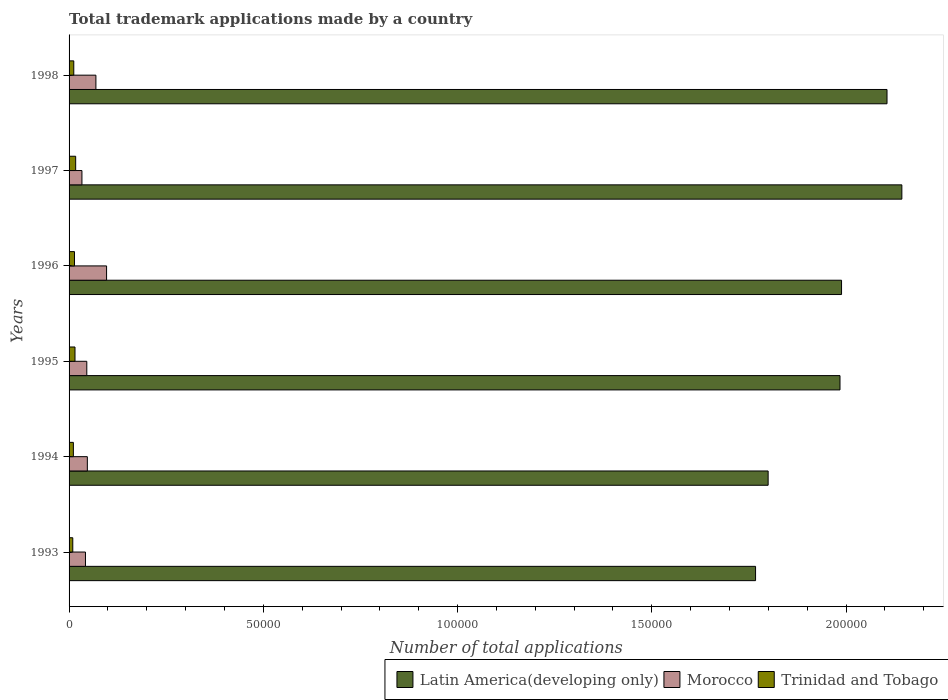How many different coloured bars are there?
Provide a succinct answer. 3. How many groups of bars are there?
Your answer should be compact. 6. How many bars are there on the 4th tick from the top?
Provide a short and direct response. 3. What is the label of the 3rd group of bars from the top?
Your answer should be compact. 1996. In how many cases, is the number of bars for a given year not equal to the number of legend labels?
Keep it short and to the point. 0. What is the number of applications made by in Latin America(developing only) in 1998?
Offer a very short reply. 2.11e+05. Across all years, what is the maximum number of applications made by in Morocco?
Provide a short and direct response. 9654. Across all years, what is the minimum number of applications made by in Morocco?
Offer a very short reply. 3312. What is the total number of applications made by in Trinidad and Tobago in the graph?
Your answer should be very brief. 7897. What is the difference between the number of applications made by in Morocco in 1993 and that in 1998?
Your response must be concise. -2688. What is the difference between the number of applications made by in Morocco in 1995 and the number of applications made by in Trinidad and Tobago in 1997?
Your answer should be very brief. 2865. What is the average number of applications made by in Morocco per year?
Your answer should be very brief. 5560. In the year 1993, what is the difference between the number of applications made by in Trinidad and Tobago and number of applications made by in Morocco?
Give a very brief answer. -3263. In how many years, is the number of applications made by in Trinidad and Tobago greater than 90000 ?
Keep it short and to the point. 0. What is the ratio of the number of applications made by in Trinidad and Tobago in 1996 to that in 1998?
Your answer should be very brief. 1.15. Is the difference between the number of applications made by in Trinidad and Tobago in 1993 and 1995 greater than the difference between the number of applications made by in Morocco in 1993 and 1995?
Give a very brief answer. No. What is the difference between the highest and the second highest number of applications made by in Latin America(developing only)?
Ensure brevity in your answer.  3819. What is the difference between the highest and the lowest number of applications made by in Latin America(developing only)?
Offer a very short reply. 3.77e+04. Is the sum of the number of applications made by in Trinidad and Tobago in 1994 and 1996 greater than the maximum number of applications made by in Morocco across all years?
Provide a short and direct response. No. What does the 3rd bar from the top in 1994 represents?
Your response must be concise. Latin America(developing only). What does the 3rd bar from the bottom in 1994 represents?
Give a very brief answer. Trinidad and Tobago. How many bars are there?
Your response must be concise. 18. Are all the bars in the graph horizontal?
Provide a succinct answer. Yes. What is the difference between two consecutive major ticks on the X-axis?
Offer a terse response. 5.00e+04. Are the values on the major ticks of X-axis written in scientific E-notation?
Provide a succinct answer. No. Does the graph contain grids?
Give a very brief answer. No. Where does the legend appear in the graph?
Offer a very short reply. Bottom right. How many legend labels are there?
Make the answer very short. 3. How are the legend labels stacked?
Your answer should be compact. Horizontal. What is the title of the graph?
Provide a succinct answer. Total trademark applications made by a country. Does "Kiribati" appear as one of the legend labels in the graph?
Ensure brevity in your answer.  No. What is the label or title of the X-axis?
Your answer should be very brief. Number of total applications. What is the Number of total applications of Latin America(developing only) in 1993?
Ensure brevity in your answer.  1.77e+05. What is the Number of total applications of Morocco in 1993?
Make the answer very short. 4220. What is the Number of total applications of Trinidad and Tobago in 1993?
Your answer should be compact. 957. What is the Number of total applications of Latin America(developing only) in 1994?
Give a very brief answer. 1.80e+05. What is the Number of total applications of Morocco in 1994?
Provide a succinct answer. 4702. What is the Number of total applications of Trinidad and Tobago in 1994?
Offer a very short reply. 1107. What is the Number of total applications in Latin America(developing only) in 1995?
Your answer should be compact. 1.98e+05. What is the Number of total applications of Morocco in 1995?
Provide a succinct answer. 4564. What is the Number of total applications of Trinidad and Tobago in 1995?
Provide a short and direct response. 1525. What is the Number of total applications in Latin America(developing only) in 1996?
Your answer should be compact. 1.99e+05. What is the Number of total applications of Morocco in 1996?
Your answer should be very brief. 9654. What is the Number of total applications in Trinidad and Tobago in 1996?
Provide a short and direct response. 1395. What is the Number of total applications of Latin America(developing only) in 1997?
Make the answer very short. 2.14e+05. What is the Number of total applications of Morocco in 1997?
Give a very brief answer. 3312. What is the Number of total applications of Trinidad and Tobago in 1997?
Offer a very short reply. 1699. What is the Number of total applications of Latin America(developing only) in 1998?
Keep it short and to the point. 2.11e+05. What is the Number of total applications in Morocco in 1998?
Ensure brevity in your answer.  6908. What is the Number of total applications of Trinidad and Tobago in 1998?
Offer a terse response. 1214. Across all years, what is the maximum Number of total applications of Latin America(developing only)?
Your answer should be very brief. 2.14e+05. Across all years, what is the maximum Number of total applications of Morocco?
Keep it short and to the point. 9654. Across all years, what is the maximum Number of total applications in Trinidad and Tobago?
Provide a succinct answer. 1699. Across all years, what is the minimum Number of total applications of Latin America(developing only)?
Your answer should be very brief. 1.77e+05. Across all years, what is the minimum Number of total applications of Morocco?
Your answer should be very brief. 3312. Across all years, what is the minimum Number of total applications in Trinidad and Tobago?
Give a very brief answer. 957. What is the total Number of total applications in Latin America(developing only) in the graph?
Your answer should be very brief. 1.18e+06. What is the total Number of total applications of Morocco in the graph?
Provide a short and direct response. 3.34e+04. What is the total Number of total applications in Trinidad and Tobago in the graph?
Provide a succinct answer. 7897. What is the difference between the Number of total applications of Latin America(developing only) in 1993 and that in 1994?
Keep it short and to the point. -3239. What is the difference between the Number of total applications of Morocco in 1993 and that in 1994?
Offer a terse response. -482. What is the difference between the Number of total applications in Trinidad and Tobago in 1993 and that in 1994?
Your answer should be compact. -150. What is the difference between the Number of total applications of Latin America(developing only) in 1993 and that in 1995?
Keep it short and to the point. -2.17e+04. What is the difference between the Number of total applications of Morocco in 1993 and that in 1995?
Keep it short and to the point. -344. What is the difference between the Number of total applications in Trinidad and Tobago in 1993 and that in 1995?
Your answer should be compact. -568. What is the difference between the Number of total applications of Latin America(developing only) in 1993 and that in 1996?
Ensure brevity in your answer.  -2.21e+04. What is the difference between the Number of total applications in Morocco in 1993 and that in 1996?
Ensure brevity in your answer.  -5434. What is the difference between the Number of total applications of Trinidad and Tobago in 1993 and that in 1996?
Your answer should be compact. -438. What is the difference between the Number of total applications of Latin America(developing only) in 1993 and that in 1997?
Keep it short and to the point. -3.77e+04. What is the difference between the Number of total applications in Morocco in 1993 and that in 1997?
Provide a short and direct response. 908. What is the difference between the Number of total applications of Trinidad and Tobago in 1993 and that in 1997?
Provide a succinct answer. -742. What is the difference between the Number of total applications of Latin America(developing only) in 1993 and that in 1998?
Ensure brevity in your answer.  -3.38e+04. What is the difference between the Number of total applications of Morocco in 1993 and that in 1998?
Provide a succinct answer. -2688. What is the difference between the Number of total applications in Trinidad and Tobago in 1993 and that in 1998?
Keep it short and to the point. -257. What is the difference between the Number of total applications in Latin America(developing only) in 1994 and that in 1995?
Offer a terse response. -1.85e+04. What is the difference between the Number of total applications of Morocco in 1994 and that in 1995?
Ensure brevity in your answer.  138. What is the difference between the Number of total applications in Trinidad and Tobago in 1994 and that in 1995?
Your response must be concise. -418. What is the difference between the Number of total applications of Latin America(developing only) in 1994 and that in 1996?
Make the answer very short. -1.89e+04. What is the difference between the Number of total applications of Morocco in 1994 and that in 1996?
Offer a very short reply. -4952. What is the difference between the Number of total applications of Trinidad and Tobago in 1994 and that in 1996?
Provide a short and direct response. -288. What is the difference between the Number of total applications in Latin America(developing only) in 1994 and that in 1997?
Your answer should be very brief. -3.44e+04. What is the difference between the Number of total applications of Morocco in 1994 and that in 1997?
Your answer should be very brief. 1390. What is the difference between the Number of total applications of Trinidad and Tobago in 1994 and that in 1997?
Offer a very short reply. -592. What is the difference between the Number of total applications of Latin America(developing only) in 1994 and that in 1998?
Offer a very short reply. -3.06e+04. What is the difference between the Number of total applications of Morocco in 1994 and that in 1998?
Offer a terse response. -2206. What is the difference between the Number of total applications of Trinidad and Tobago in 1994 and that in 1998?
Provide a short and direct response. -107. What is the difference between the Number of total applications in Latin America(developing only) in 1995 and that in 1996?
Make the answer very short. -396. What is the difference between the Number of total applications of Morocco in 1995 and that in 1996?
Make the answer very short. -5090. What is the difference between the Number of total applications of Trinidad and Tobago in 1995 and that in 1996?
Make the answer very short. 130. What is the difference between the Number of total applications of Latin America(developing only) in 1995 and that in 1997?
Provide a short and direct response. -1.59e+04. What is the difference between the Number of total applications in Morocco in 1995 and that in 1997?
Provide a short and direct response. 1252. What is the difference between the Number of total applications of Trinidad and Tobago in 1995 and that in 1997?
Offer a terse response. -174. What is the difference between the Number of total applications in Latin America(developing only) in 1995 and that in 1998?
Provide a short and direct response. -1.21e+04. What is the difference between the Number of total applications of Morocco in 1995 and that in 1998?
Provide a succinct answer. -2344. What is the difference between the Number of total applications of Trinidad and Tobago in 1995 and that in 1998?
Give a very brief answer. 311. What is the difference between the Number of total applications in Latin America(developing only) in 1996 and that in 1997?
Offer a terse response. -1.55e+04. What is the difference between the Number of total applications of Morocco in 1996 and that in 1997?
Offer a terse response. 6342. What is the difference between the Number of total applications of Trinidad and Tobago in 1996 and that in 1997?
Provide a short and direct response. -304. What is the difference between the Number of total applications in Latin America(developing only) in 1996 and that in 1998?
Offer a terse response. -1.17e+04. What is the difference between the Number of total applications in Morocco in 1996 and that in 1998?
Provide a succinct answer. 2746. What is the difference between the Number of total applications of Trinidad and Tobago in 1996 and that in 1998?
Your answer should be very brief. 181. What is the difference between the Number of total applications of Latin America(developing only) in 1997 and that in 1998?
Ensure brevity in your answer.  3819. What is the difference between the Number of total applications of Morocco in 1997 and that in 1998?
Provide a succinct answer. -3596. What is the difference between the Number of total applications in Trinidad and Tobago in 1997 and that in 1998?
Provide a succinct answer. 485. What is the difference between the Number of total applications of Latin America(developing only) in 1993 and the Number of total applications of Morocco in 1994?
Provide a succinct answer. 1.72e+05. What is the difference between the Number of total applications of Latin America(developing only) in 1993 and the Number of total applications of Trinidad and Tobago in 1994?
Give a very brief answer. 1.76e+05. What is the difference between the Number of total applications of Morocco in 1993 and the Number of total applications of Trinidad and Tobago in 1994?
Give a very brief answer. 3113. What is the difference between the Number of total applications in Latin America(developing only) in 1993 and the Number of total applications in Morocco in 1995?
Provide a short and direct response. 1.72e+05. What is the difference between the Number of total applications of Latin America(developing only) in 1993 and the Number of total applications of Trinidad and Tobago in 1995?
Make the answer very short. 1.75e+05. What is the difference between the Number of total applications in Morocco in 1993 and the Number of total applications in Trinidad and Tobago in 1995?
Your answer should be very brief. 2695. What is the difference between the Number of total applications of Latin America(developing only) in 1993 and the Number of total applications of Morocco in 1996?
Offer a very short reply. 1.67e+05. What is the difference between the Number of total applications in Latin America(developing only) in 1993 and the Number of total applications in Trinidad and Tobago in 1996?
Provide a short and direct response. 1.75e+05. What is the difference between the Number of total applications in Morocco in 1993 and the Number of total applications in Trinidad and Tobago in 1996?
Your answer should be very brief. 2825. What is the difference between the Number of total applications of Latin America(developing only) in 1993 and the Number of total applications of Morocco in 1997?
Your answer should be compact. 1.73e+05. What is the difference between the Number of total applications of Latin America(developing only) in 1993 and the Number of total applications of Trinidad and Tobago in 1997?
Provide a short and direct response. 1.75e+05. What is the difference between the Number of total applications in Morocco in 1993 and the Number of total applications in Trinidad and Tobago in 1997?
Your response must be concise. 2521. What is the difference between the Number of total applications of Latin America(developing only) in 1993 and the Number of total applications of Morocco in 1998?
Offer a terse response. 1.70e+05. What is the difference between the Number of total applications of Latin America(developing only) in 1993 and the Number of total applications of Trinidad and Tobago in 1998?
Your answer should be compact. 1.75e+05. What is the difference between the Number of total applications in Morocco in 1993 and the Number of total applications in Trinidad and Tobago in 1998?
Your answer should be very brief. 3006. What is the difference between the Number of total applications in Latin America(developing only) in 1994 and the Number of total applications in Morocco in 1995?
Make the answer very short. 1.75e+05. What is the difference between the Number of total applications in Latin America(developing only) in 1994 and the Number of total applications in Trinidad and Tobago in 1995?
Ensure brevity in your answer.  1.78e+05. What is the difference between the Number of total applications in Morocco in 1994 and the Number of total applications in Trinidad and Tobago in 1995?
Keep it short and to the point. 3177. What is the difference between the Number of total applications of Latin America(developing only) in 1994 and the Number of total applications of Morocco in 1996?
Your answer should be very brief. 1.70e+05. What is the difference between the Number of total applications of Latin America(developing only) in 1994 and the Number of total applications of Trinidad and Tobago in 1996?
Your answer should be very brief. 1.79e+05. What is the difference between the Number of total applications in Morocco in 1994 and the Number of total applications in Trinidad and Tobago in 1996?
Provide a short and direct response. 3307. What is the difference between the Number of total applications in Latin America(developing only) in 1994 and the Number of total applications in Morocco in 1997?
Your answer should be very brief. 1.77e+05. What is the difference between the Number of total applications in Latin America(developing only) in 1994 and the Number of total applications in Trinidad and Tobago in 1997?
Ensure brevity in your answer.  1.78e+05. What is the difference between the Number of total applications in Morocco in 1994 and the Number of total applications in Trinidad and Tobago in 1997?
Give a very brief answer. 3003. What is the difference between the Number of total applications of Latin America(developing only) in 1994 and the Number of total applications of Morocco in 1998?
Make the answer very short. 1.73e+05. What is the difference between the Number of total applications in Latin America(developing only) in 1994 and the Number of total applications in Trinidad and Tobago in 1998?
Ensure brevity in your answer.  1.79e+05. What is the difference between the Number of total applications of Morocco in 1994 and the Number of total applications of Trinidad and Tobago in 1998?
Your answer should be very brief. 3488. What is the difference between the Number of total applications in Latin America(developing only) in 1995 and the Number of total applications in Morocco in 1996?
Keep it short and to the point. 1.89e+05. What is the difference between the Number of total applications of Latin America(developing only) in 1995 and the Number of total applications of Trinidad and Tobago in 1996?
Ensure brevity in your answer.  1.97e+05. What is the difference between the Number of total applications of Morocco in 1995 and the Number of total applications of Trinidad and Tobago in 1996?
Provide a succinct answer. 3169. What is the difference between the Number of total applications of Latin America(developing only) in 1995 and the Number of total applications of Morocco in 1997?
Ensure brevity in your answer.  1.95e+05. What is the difference between the Number of total applications in Latin America(developing only) in 1995 and the Number of total applications in Trinidad and Tobago in 1997?
Make the answer very short. 1.97e+05. What is the difference between the Number of total applications in Morocco in 1995 and the Number of total applications in Trinidad and Tobago in 1997?
Ensure brevity in your answer.  2865. What is the difference between the Number of total applications in Latin America(developing only) in 1995 and the Number of total applications in Morocco in 1998?
Keep it short and to the point. 1.92e+05. What is the difference between the Number of total applications of Latin America(developing only) in 1995 and the Number of total applications of Trinidad and Tobago in 1998?
Your answer should be very brief. 1.97e+05. What is the difference between the Number of total applications of Morocco in 1995 and the Number of total applications of Trinidad and Tobago in 1998?
Ensure brevity in your answer.  3350. What is the difference between the Number of total applications of Latin America(developing only) in 1996 and the Number of total applications of Morocco in 1997?
Provide a short and direct response. 1.96e+05. What is the difference between the Number of total applications of Latin America(developing only) in 1996 and the Number of total applications of Trinidad and Tobago in 1997?
Keep it short and to the point. 1.97e+05. What is the difference between the Number of total applications in Morocco in 1996 and the Number of total applications in Trinidad and Tobago in 1997?
Ensure brevity in your answer.  7955. What is the difference between the Number of total applications of Latin America(developing only) in 1996 and the Number of total applications of Morocco in 1998?
Your answer should be compact. 1.92e+05. What is the difference between the Number of total applications of Latin America(developing only) in 1996 and the Number of total applications of Trinidad and Tobago in 1998?
Ensure brevity in your answer.  1.98e+05. What is the difference between the Number of total applications in Morocco in 1996 and the Number of total applications in Trinidad and Tobago in 1998?
Give a very brief answer. 8440. What is the difference between the Number of total applications of Latin America(developing only) in 1997 and the Number of total applications of Morocco in 1998?
Keep it short and to the point. 2.07e+05. What is the difference between the Number of total applications of Latin America(developing only) in 1997 and the Number of total applications of Trinidad and Tobago in 1998?
Keep it short and to the point. 2.13e+05. What is the difference between the Number of total applications of Morocco in 1997 and the Number of total applications of Trinidad and Tobago in 1998?
Provide a short and direct response. 2098. What is the average Number of total applications of Latin America(developing only) per year?
Ensure brevity in your answer.  1.96e+05. What is the average Number of total applications in Morocco per year?
Your answer should be compact. 5560. What is the average Number of total applications of Trinidad and Tobago per year?
Offer a very short reply. 1316.17. In the year 1993, what is the difference between the Number of total applications of Latin America(developing only) and Number of total applications of Morocco?
Keep it short and to the point. 1.72e+05. In the year 1993, what is the difference between the Number of total applications of Latin America(developing only) and Number of total applications of Trinidad and Tobago?
Your response must be concise. 1.76e+05. In the year 1993, what is the difference between the Number of total applications of Morocco and Number of total applications of Trinidad and Tobago?
Offer a very short reply. 3263. In the year 1994, what is the difference between the Number of total applications of Latin America(developing only) and Number of total applications of Morocco?
Offer a terse response. 1.75e+05. In the year 1994, what is the difference between the Number of total applications in Latin America(developing only) and Number of total applications in Trinidad and Tobago?
Your response must be concise. 1.79e+05. In the year 1994, what is the difference between the Number of total applications of Morocco and Number of total applications of Trinidad and Tobago?
Your answer should be compact. 3595. In the year 1995, what is the difference between the Number of total applications of Latin America(developing only) and Number of total applications of Morocco?
Ensure brevity in your answer.  1.94e+05. In the year 1995, what is the difference between the Number of total applications in Latin America(developing only) and Number of total applications in Trinidad and Tobago?
Provide a succinct answer. 1.97e+05. In the year 1995, what is the difference between the Number of total applications in Morocco and Number of total applications in Trinidad and Tobago?
Keep it short and to the point. 3039. In the year 1996, what is the difference between the Number of total applications of Latin America(developing only) and Number of total applications of Morocco?
Your response must be concise. 1.89e+05. In the year 1996, what is the difference between the Number of total applications in Latin America(developing only) and Number of total applications in Trinidad and Tobago?
Keep it short and to the point. 1.97e+05. In the year 1996, what is the difference between the Number of total applications in Morocco and Number of total applications in Trinidad and Tobago?
Keep it short and to the point. 8259. In the year 1997, what is the difference between the Number of total applications of Latin America(developing only) and Number of total applications of Morocco?
Your answer should be very brief. 2.11e+05. In the year 1997, what is the difference between the Number of total applications in Latin America(developing only) and Number of total applications in Trinidad and Tobago?
Provide a short and direct response. 2.13e+05. In the year 1997, what is the difference between the Number of total applications of Morocco and Number of total applications of Trinidad and Tobago?
Give a very brief answer. 1613. In the year 1998, what is the difference between the Number of total applications of Latin America(developing only) and Number of total applications of Morocco?
Your answer should be very brief. 2.04e+05. In the year 1998, what is the difference between the Number of total applications of Latin America(developing only) and Number of total applications of Trinidad and Tobago?
Provide a succinct answer. 2.09e+05. In the year 1998, what is the difference between the Number of total applications in Morocco and Number of total applications in Trinidad and Tobago?
Keep it short and to the point. 5694. What is the ratio of the Number of total applications in Morocco in 1993 to that in 1994?
Your response must be concise. 0.9. What is the ratio of the Number of total applications in Trinidad and Tobago in 1993 to that in 1994?
Provide a short and direct response. 0.86. What is the ratio of the Number of total applications in Latin America(developing only) in 1993 to that in 1995?
Your response must be concise. 0.89. What is the ratio of the Number of total applications of Morocco in 1993 to that in 1995?
Make the answer very short. 0.92. What is the ratio of the Number of total applications in Trinidad and Tobago in 1993 to that in 1995?
Give a very brief answer. 0.63. What is the ratio of the Number of total applications of Latin America(developing only) in 1993 to that in 1996?
Ensure brevity in your answer.  0.89. What is the ratio of the Number of total applications of Morocco in 1993 to that in 1996?
Keep it short and to the point. 0.44. What is the ratio of the Number of total applications of Trinidad and Tobago in 1993 to that in 1996?
Ensure brevity in your answer.  0.69. What is the ratio of the Number of total applications in Latin America(developing only) in 1993 to that in 1997?
Offer a terse response. 0.82. What is the ratio of the Number of total applications in Morocco in 1993 to that in 1997?
Offer a very short reply. 1.27. What is the ratio of the Number of total applications in Trinidad and Tobago in 1993 to that in 1997?
Your answer should be compact. 0.56. What is the ratio of the Number of total applications of Latin America(developing only) in 1993 to that in 1998?
Provide a succinct answer. 0.84. What is the ratio of the Number of total applications of Morocco in 1993 to that in 1998?
Ensure brevity in your answer.  0.61. What is the ratio of the Number of total applications of Trinidad and Tobago in 1993 to that in 1998?
Provide a short and direct response. 0.79. What is the ratio of the Number of total applications of Latin America(developing only) in 1994 to that in 1995?
Provide a succinct answer. 0.91. What is the ratio of the Number of total applications in Morocco in 1994 to that in 1995?
Provide a succinct answer. 1.03. What is the ratio of the Number of total applications of Trinidad and Tobago in 1994 to that in 1995?
Offer a terse response. 0.73. What is the ratio of the Number of total applications in Latin America(developing only) in 1994 to that in 1996?
Provide a succinct answer. 0.91. What is the ratio of the Number of total applications in Morocco in 1994 to that in 1996?
Offer a very short reply. 0.49. What is the ratio of the Number of total applications of Trinidad and Tobago in 1994 to that in 1996?
Make the answer very short. 0.79. What is the ratio of the Number of total applications of Latin America(developing only) in 1994 to that in 1997?
Your response must be concise. 0.84. What is the ratio of the Number of total applications in Morocco in 1994 to that in 1997?
Give a very brief answer. 1.42. What is the ratio of the Number of total applications of Trinidad and Tobago in 1994 to that in 1997?
Offer a very short reply. 0.65. What is the ratio of the Number of total applications of Latin America(developing only) in 1994 to that in 1998?
Provide a short and direct response. 0.85. What is the ratio of the Number of total applications in Morocco in 1994 to that in 1998?
Provide a succinct answer. 0.68. What is the ratio of the Number of total applications of Trinidad and Tobago in 1994 to that in 1998?
Provide a succinct answer. 0.91. What is the ratio of the Number of total applications of Morocco in 1995 to that in 1996?
Provide a succinct answer. 0.47. What is the ratio of the Number of total applications in Trinidad and Tobago in 1995 to that in 1996?
Provide a short and direct response. 1.09. What is the ratio of the Number of total applications of Latin America(developing only) in 1995 to that in 1997?
Offer a terse response. 0.93. What is the ratio of the Number of total applications of Morocco in 1995 to that in 1997?
Make the answer very short. 1.38. What is the ratio of the Number of total applications in Trinidad and Tobago in 1995 to that in 1997?
Keep it short and to the point. 0.9. What is the ratio of the Number of total applications in Latin America(developing only) in 1995 to that in 1998?
Your answer should be very brief. 0.94. What is the ratio of the Number of total applications in Morocco in 1995 to that in 1998?
Give a very brief answer. 0.66. What is the ratio of the Number of total applications of Trinidad and Tobago in 1995 to that in 1998?
Give a very brief answer. 1.26. What is the ratio of the Number of total applications of Latin America(developing only) in 1996 to that in 1997?
Make the answer very short. 0.93. What is the ratio of the Number of total applications in Morocco in 1996 to that in 1997?
Provide a succinct answer. 2.91. What is the ratio of the Number of total applications in Trinidad and Tobago in 1996 to that in 1997?
Your answer should be compact. 0.82. What is the ratio of the Number of total applications in Morocco in 1996 to that in 1998?
Keep it short and to the point. 1.4. What is the ratio of the Number of total applications in Trinidad and Tobago in 1996 to that in 1998?
Offer a very short reply. 1.15. What is the ratio of the Number of total applications in Latin America(developing only) in 1997 to that in 1998?
Give a very brief answer. 1.02. What is the ratio of the Number of total applications of Morocco in 1997 to that in 1998?
Offer a very short reply. 0.48. What is the ratio of the Number of total applications of Trinidad and Tobago in 1997 to that in 1998?
Offer a terse response. 1.4. What is the difference between the highest and the second highest Number of total applications of Latin America(developing only)?
Make the answer very short. 3819. What is the difference between the highest and the second highest Number of total applications in Morocco?
Provide a short and direct response. 2746. What is the difference between the highest and the second highest Number of total applications of Trinidad and Tobago?
Offer a terse response. 174. What is the difference between the highest and the lowest Number of total applications of Latin America(developing only)?
Keep it short and to the point. 3.77e+04. What is the difference between the highest and the lowest Number of total applications of Morocco?
Give a very brief answer. 6342. What is the difference between the highest and the lowest Number of total applications in Trinidad and Tobago?
Your answer should be compact. 742. 